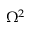<formula> <loc_0><loc_0><loc_500><loc_500>\Omega ^ { 2 }</formula> 